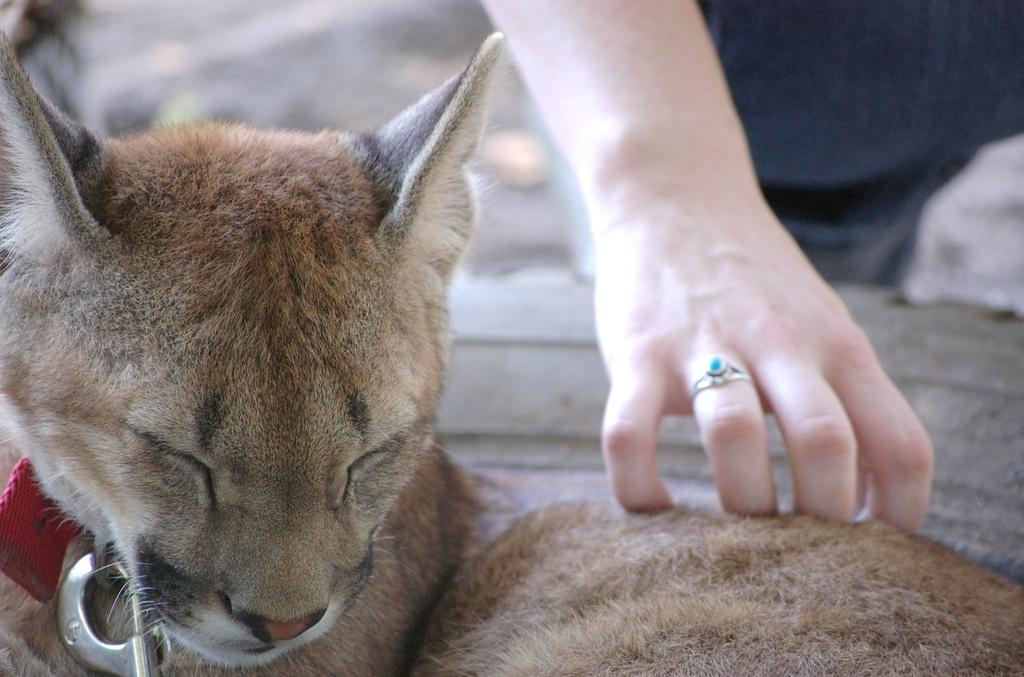What type of animal is in the image? There is a cat in the image. What is the cat doing in the image? The cat is sitting and sleeping. Is there any interaction between the cat and a person in the image? Yes, a person is touching the cat with their hand. What is the name of the cushion the cat is sitting on in the image? There is no cushion present in the image; the cat is sitting on the floor. Who is the manager of the cat in the image? The image does not depict a manager or any indication of a hierarchy involving the cat. 